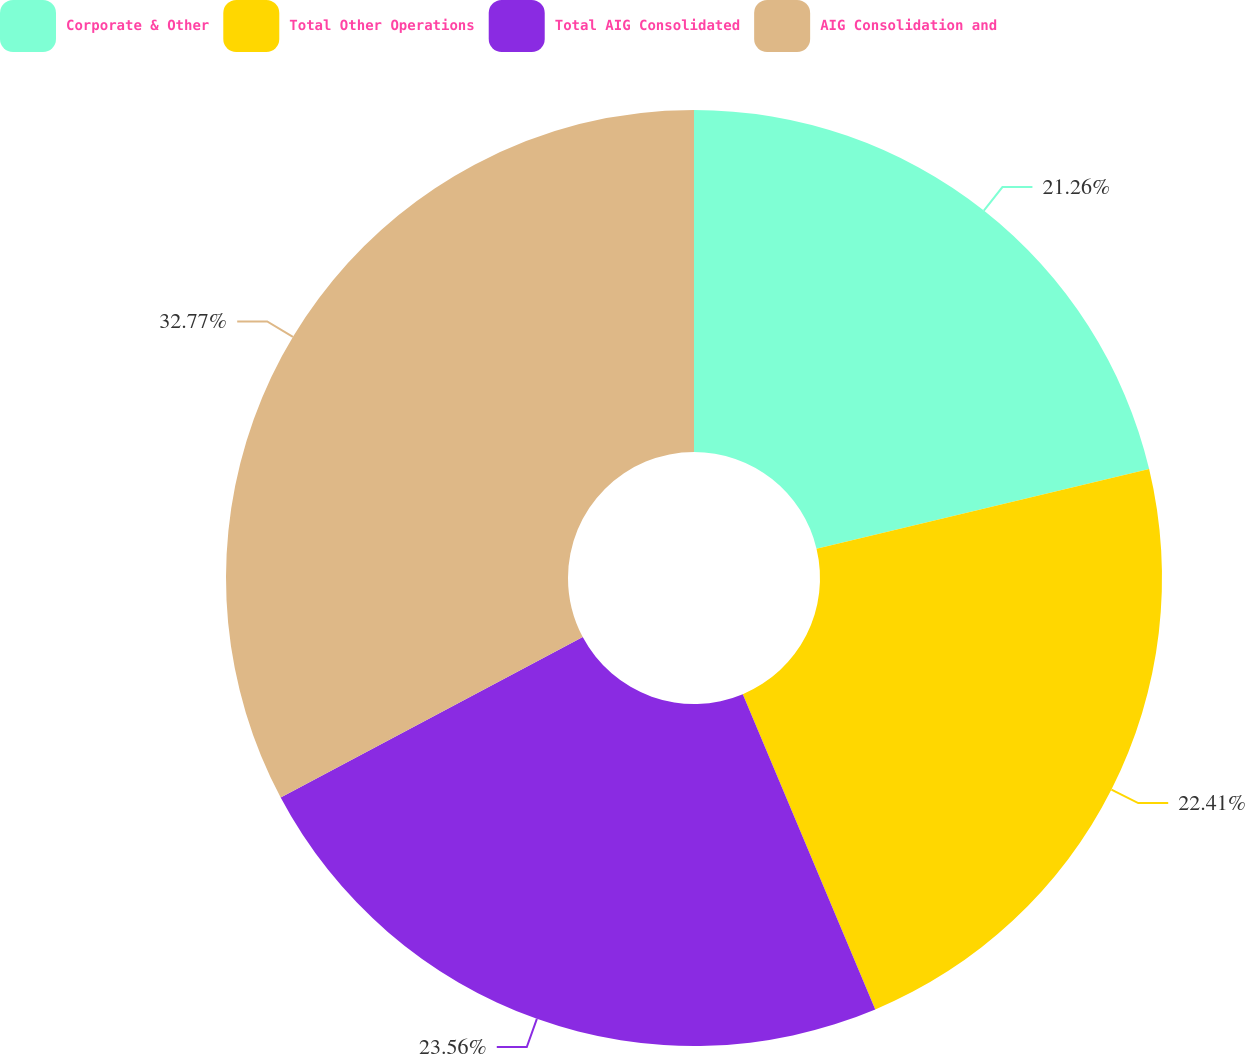Convert chart to OTSL. <chart><loc_0><loc_0><loc_500><loc_500><pie_chart><fcel>Corporate & Other<fcel>Total Other Operations<fcel>Total AIG Consolidated<fcel>AIG Consolidation and<nl><fcel>21.26%<fcel>22.41%<fcel>23.56%<fcel>32.77%<nl></chart> 